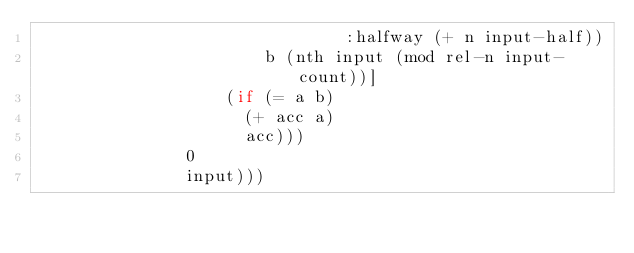Convert code to text. <code><loc_0><loc_0><loc_500><loc_500><_Clojure_>                               :halfway (+ n input-half))
                       b (nth input (mod rel-n input-count))]
                   (if (= a b)
                     (+ acc a)
                     acc)))
               0
               input)))
</code> 